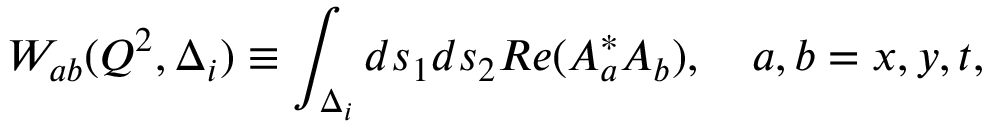<formula> <loc_0><loc_0><loc_500><loc_500>W _ { a b } ( Q ^ { 2 } , \Delta _ { i } ) \equiv \int _ { \Delta _ { i } } d s _ { 1 } d s _ { 2 } R e ( A _ { a } ^ { * } A _ { b } ) , a , b = x , y , t ,</formula> 